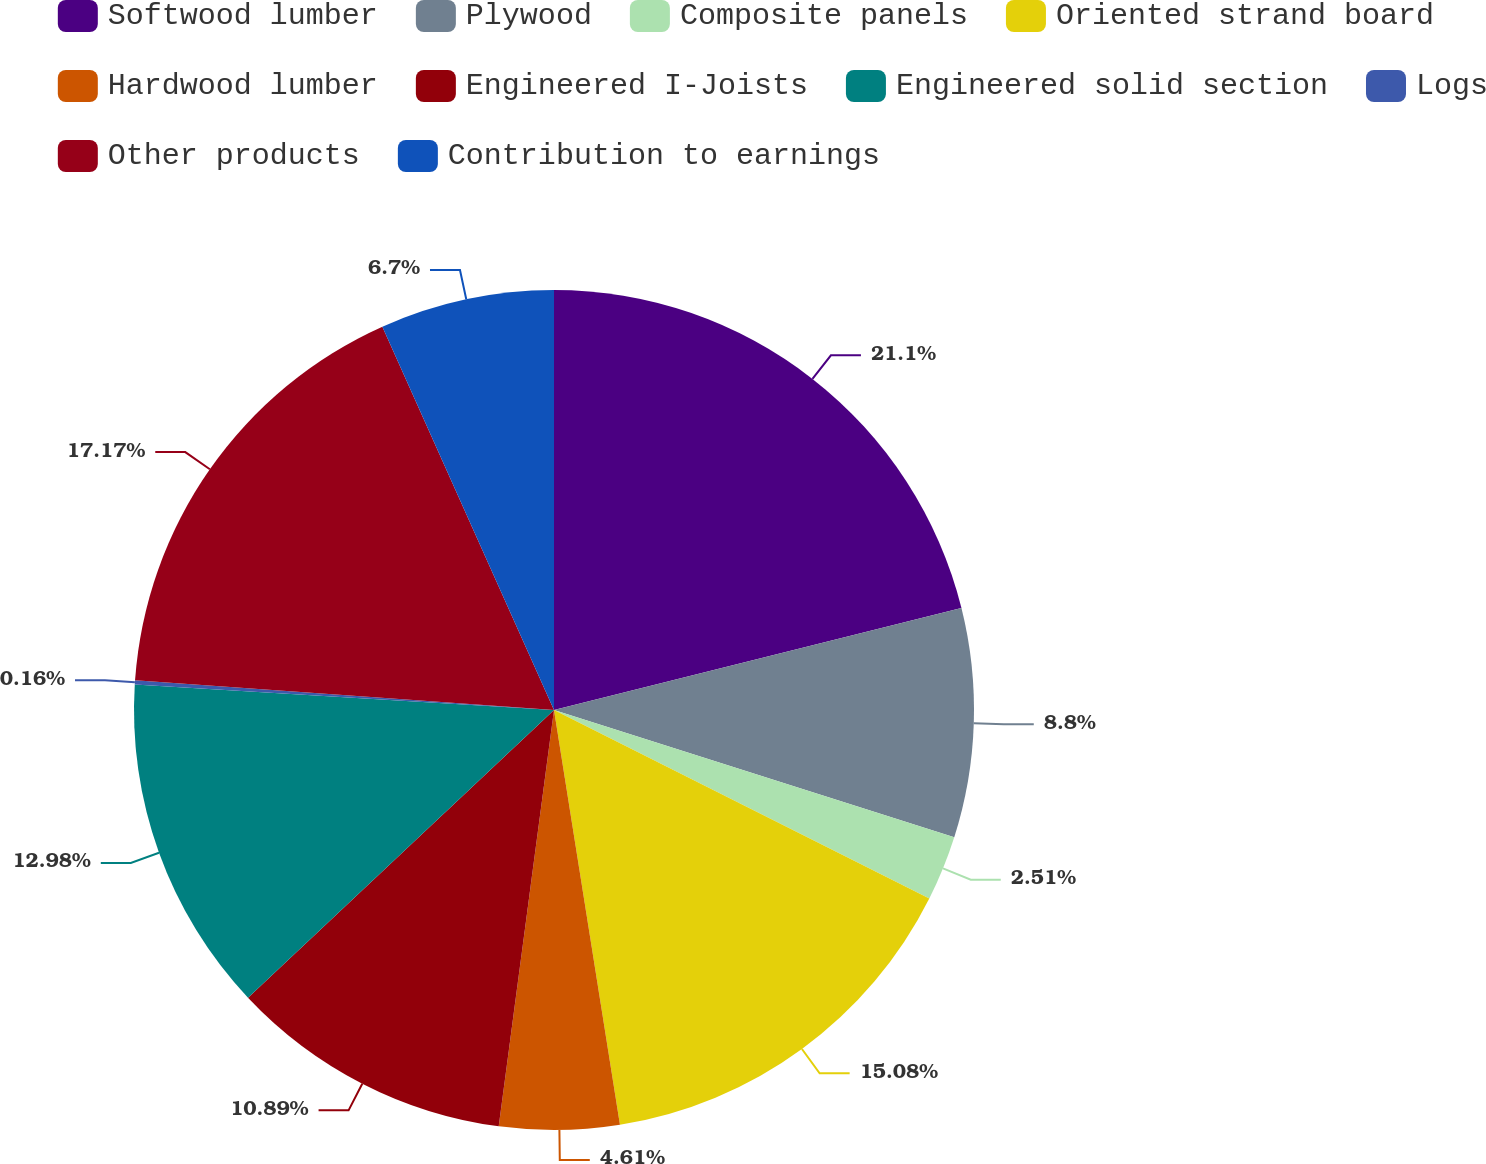Convert chart. <chart><loc_0><loc_0><loc_500><loc_500><pie_chart><fcel>Softwood lumber<fcel>Plywood<fcel>Composite panels<fcel>Oriented strand board<fcel>Hardwood lumber<fcel>Engineered I-Joists<fcel>Engineered solid section<fcel>Logs<fcel>Other products<fcel>Contribution to earnings<nl><fcel>21.1%<fcel>8.8%<fcel>2.51%<fcel>15.08%<fcel>4.61%<fcel>10.89%<fcel>12.98%<fcel>0.16%<fcel>17.17%<fcel>6.7%<nl></chart> 